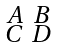Convert formula to latex. <formula><loc_0><loc_0><loc_500><loc_500>\begin{smallmatrix} A & B \\ C & D \end{smallmatrix}</formula> 